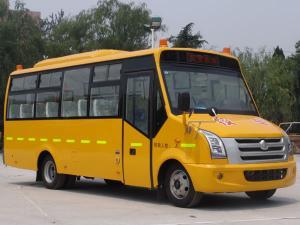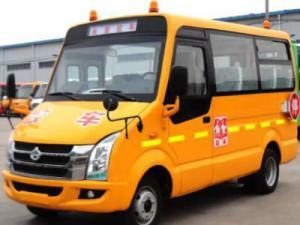The first image is the image on the left, the second image is the image on the right. Considering the images on both sides, is "A bus with sculpted cartoon characters across the top is visible." valid? Answer yes or no. No. The first image is the image on the left, the second image is the image on the right. For the images shown, is this caption "One bus has cartoon characters on the roof." true? Answer yes or no. No. 